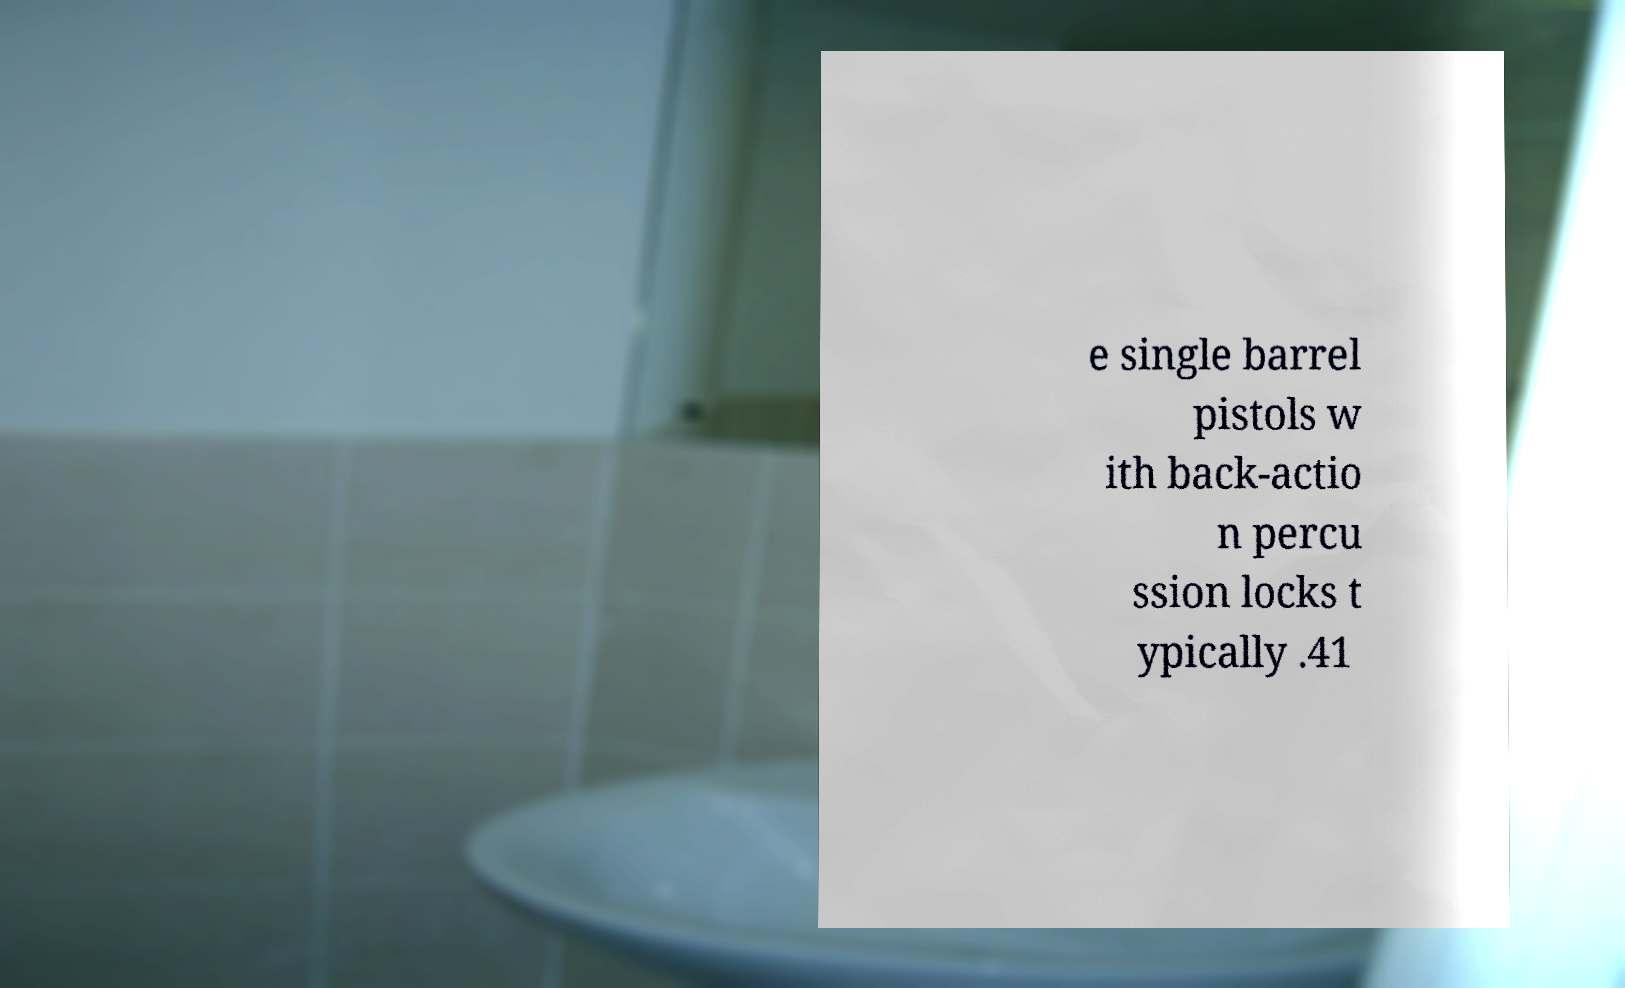Please identify and transcribe the text found in this image. e single barrel pistols w ith back-actio n percu ssion locks t ypically .41 